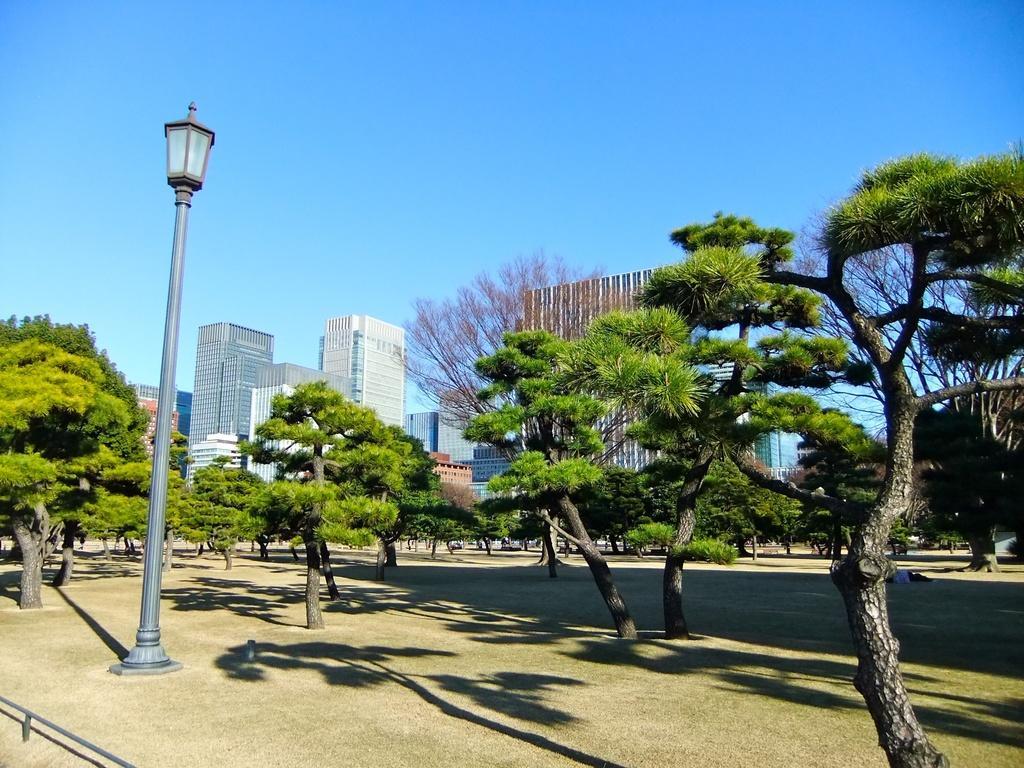How would you summarize this image in a sentence or two? In this image I see the ground on which there are number of trees and I see a light pole over here. In the background I see the buildings and the blue sky. 